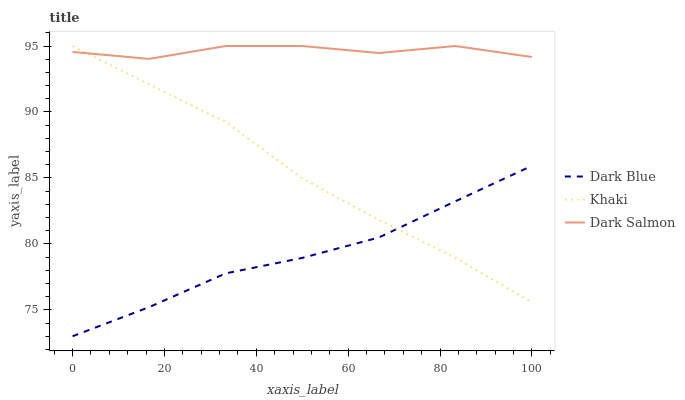Does Dark Blue have the minimum area under the curve?
Answer yes or no. Yes. Does Dark Salmon have the maximum area under the curve?
Answer yes or no. Yes. Does Khaki have the minimum area under the curve?
Answer yes or no. No. Does Khaki have the maximum area under the curve?
Answer yes or no. No. Is Dark Blue the smoothest?
Answer yes or no. Yes. Is Dark Salmon the roughest?
Answer yes or no. Yes. Is Khaki the smoothest?
Answer yes or no. No. Is Khaki the roughest?
Answer yes or no. No. Does Dark Blue have the lowest value?
Answer yes or no. Yes. Does Khaki have the lowest value?
Answer yes or no. No. Does Dark Salmon have the highest value?
Answer yes or no. Yes. Is Dark Blue less than Dark Salmon?
Answer yes or no. Yes. Is Dark Salmon greater than Dark Blue?
Answer yes or no. Yes. Does Dark Salmon intersect Khaki?
Answer yes or no. Yes. Is Dark Salmon less than Khaki?
Answer yes or no. No. Is Dark Salmon greater than Khaki?
Answer yes or no. No. Does Dark Blue intersect Dark Salmon?
Answer yes or no. No. 